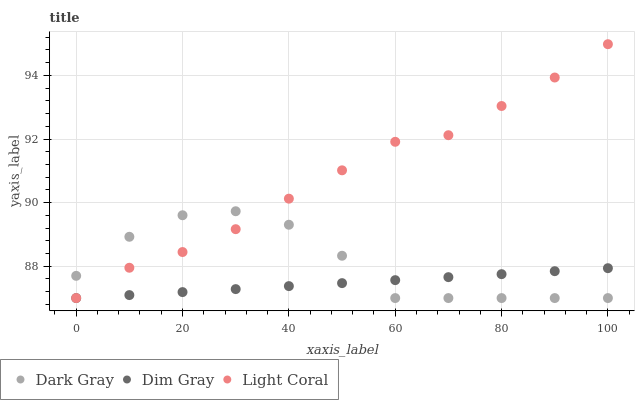Does Dim Gray have the minimum area under the curve?
Answer yes or no. Yes. Does Light Coral have the maximum area under the curve?
Answer yes or no. Yes. Does Light Coral have the minimum area under the curve?
Answer yes or no. No. Does Dim Gray have the maximum area under the curve?
Answer yes or no. No. Is Dim Gray the smoothest?
Answer yes or no. Yes. Is Dark Gray the roughest?
Answer yes or no. Yes. Is Light Coral the smoothest?
Answer yes or no. No. Is Light Coral the roughest?
Answer yes or no. No. Does Dark Gray have the lowest value?
Answer yes or no. Yes. Does Light Coral have the highest value?
Answer yes or no. Yes. Does Dim Gray have the highest value?
Answer yes or no. No. Does Dim Gray intersect Light Coral?
Answer yes or no. Yes. Is Dim Gray less than Light Coral?
Answer yes or no. No. Is Dim Gray greater than Light Coral?
Answer yes or no. No. 